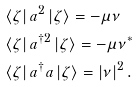<formula> <loc_0><loc_0><loc_500><loc_500>& \left < \zeta \right | a ^ { 2 } \left | \zeta \right > = - \mu \nu \\ & \left < \zeta \right | a ^ { \dagger 2 } \left | \zeta \right > = - \mu \nu ^ { * } \\ & \left < \zeta \right | a ^ { \dagger } a \left | \zeta \right > = \left | \nu \right | ^ { 2 } .</formula> 